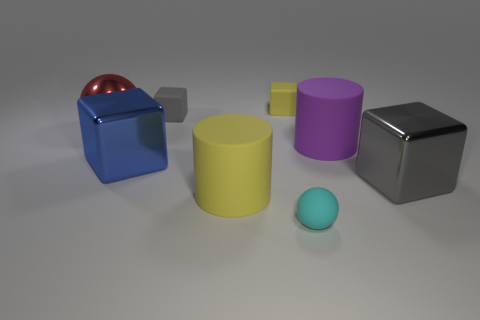What number of other tiny yellow rubber things are the same shape as the small yellow rubber object?
Your response must be concise. 0. The big blue metal object is what shape?
Your answer should be very brief. Cube. Are there fewer metal balls than tiny blue matte objects?
Offer a very short reply. No. Are there any other things that have the same size as the red metallic thing?
Provide a short and direct response. Yes. There is a blue object that is the same shape as the small yellow matte thing; what material is it?
Make the answer very short. Metal. Are there more red metal objects than metallic blocks?
Your answer should be very brief. No. What number of other things are the same color as the large ball?
Offer a terse response. 0. Is the big purple cylinder made of the same material as the large cube that is left of the cyan matte thing?
Provide a succinct answer. No. How many gray objects are left of the large cube that is to the left of the gray thing that is in front of the red object?
Offer a terse response. 0. Is the number of metallic objects that are behind the large blue object less than the number of big blue metal things behind the metallic sphere?
Provide a succinct answer. No. 